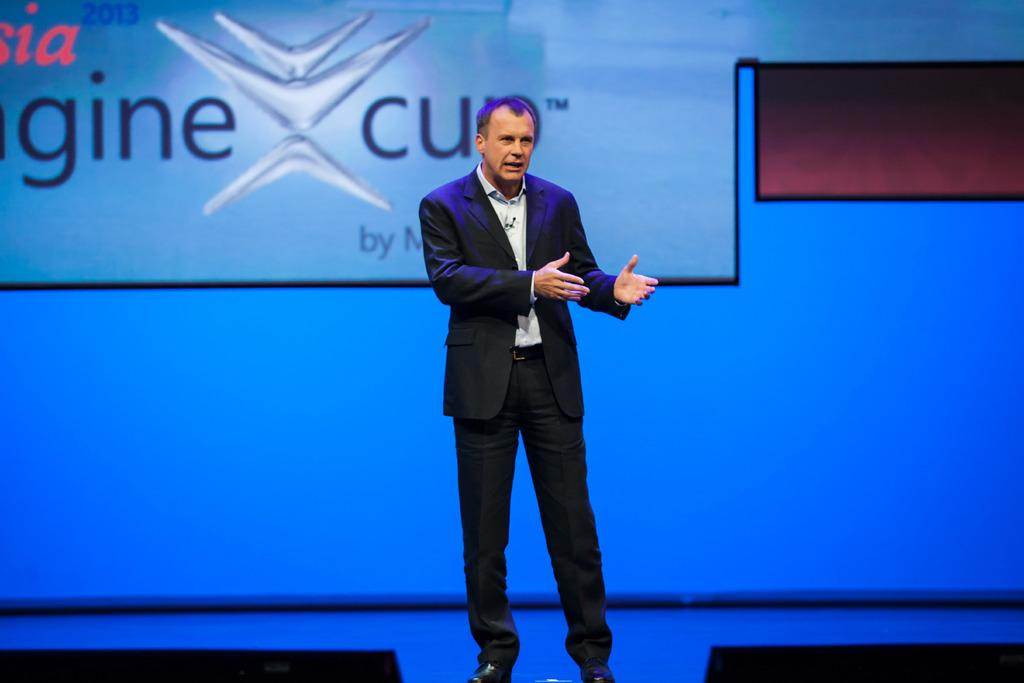Who or what is the main subject in the center of the image? There is a person in the center of the image. What is located behind the person? There is a screen behind the person. What type of cat can be seen playing with a soda can on the screen? There is no cat or soda can present on the screen in the image. 